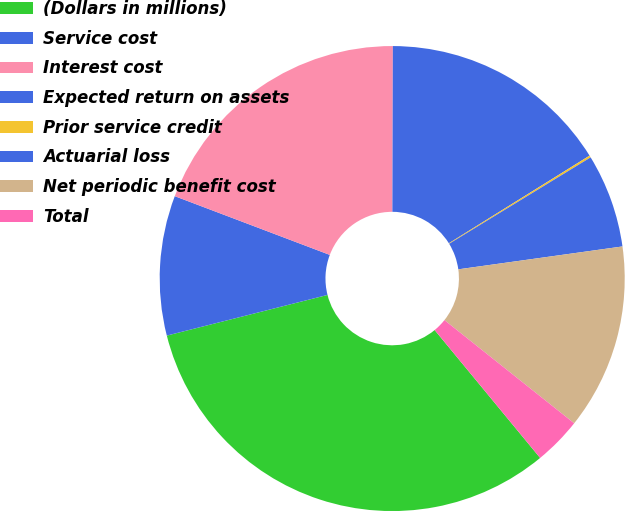<chart> <loc_0><loc_0><loc_500><loc_500><pie_chart><fcel>(Dollars in millions)<fcel>Service cost<fcel>Interest cost<fcel>Expected return on assets<fcel>Prior service credit<fcel>Actuarial loss<fcel>Net periodic benefit cost<fcel>Total<nl><fcel>32.03%<fcel>9.71%<fcel>19.28%<fcel>16.09%<fcel>0.14%<fcel>6.52%<fcel>12.9%<fcel>3.33%<nl></chart> 